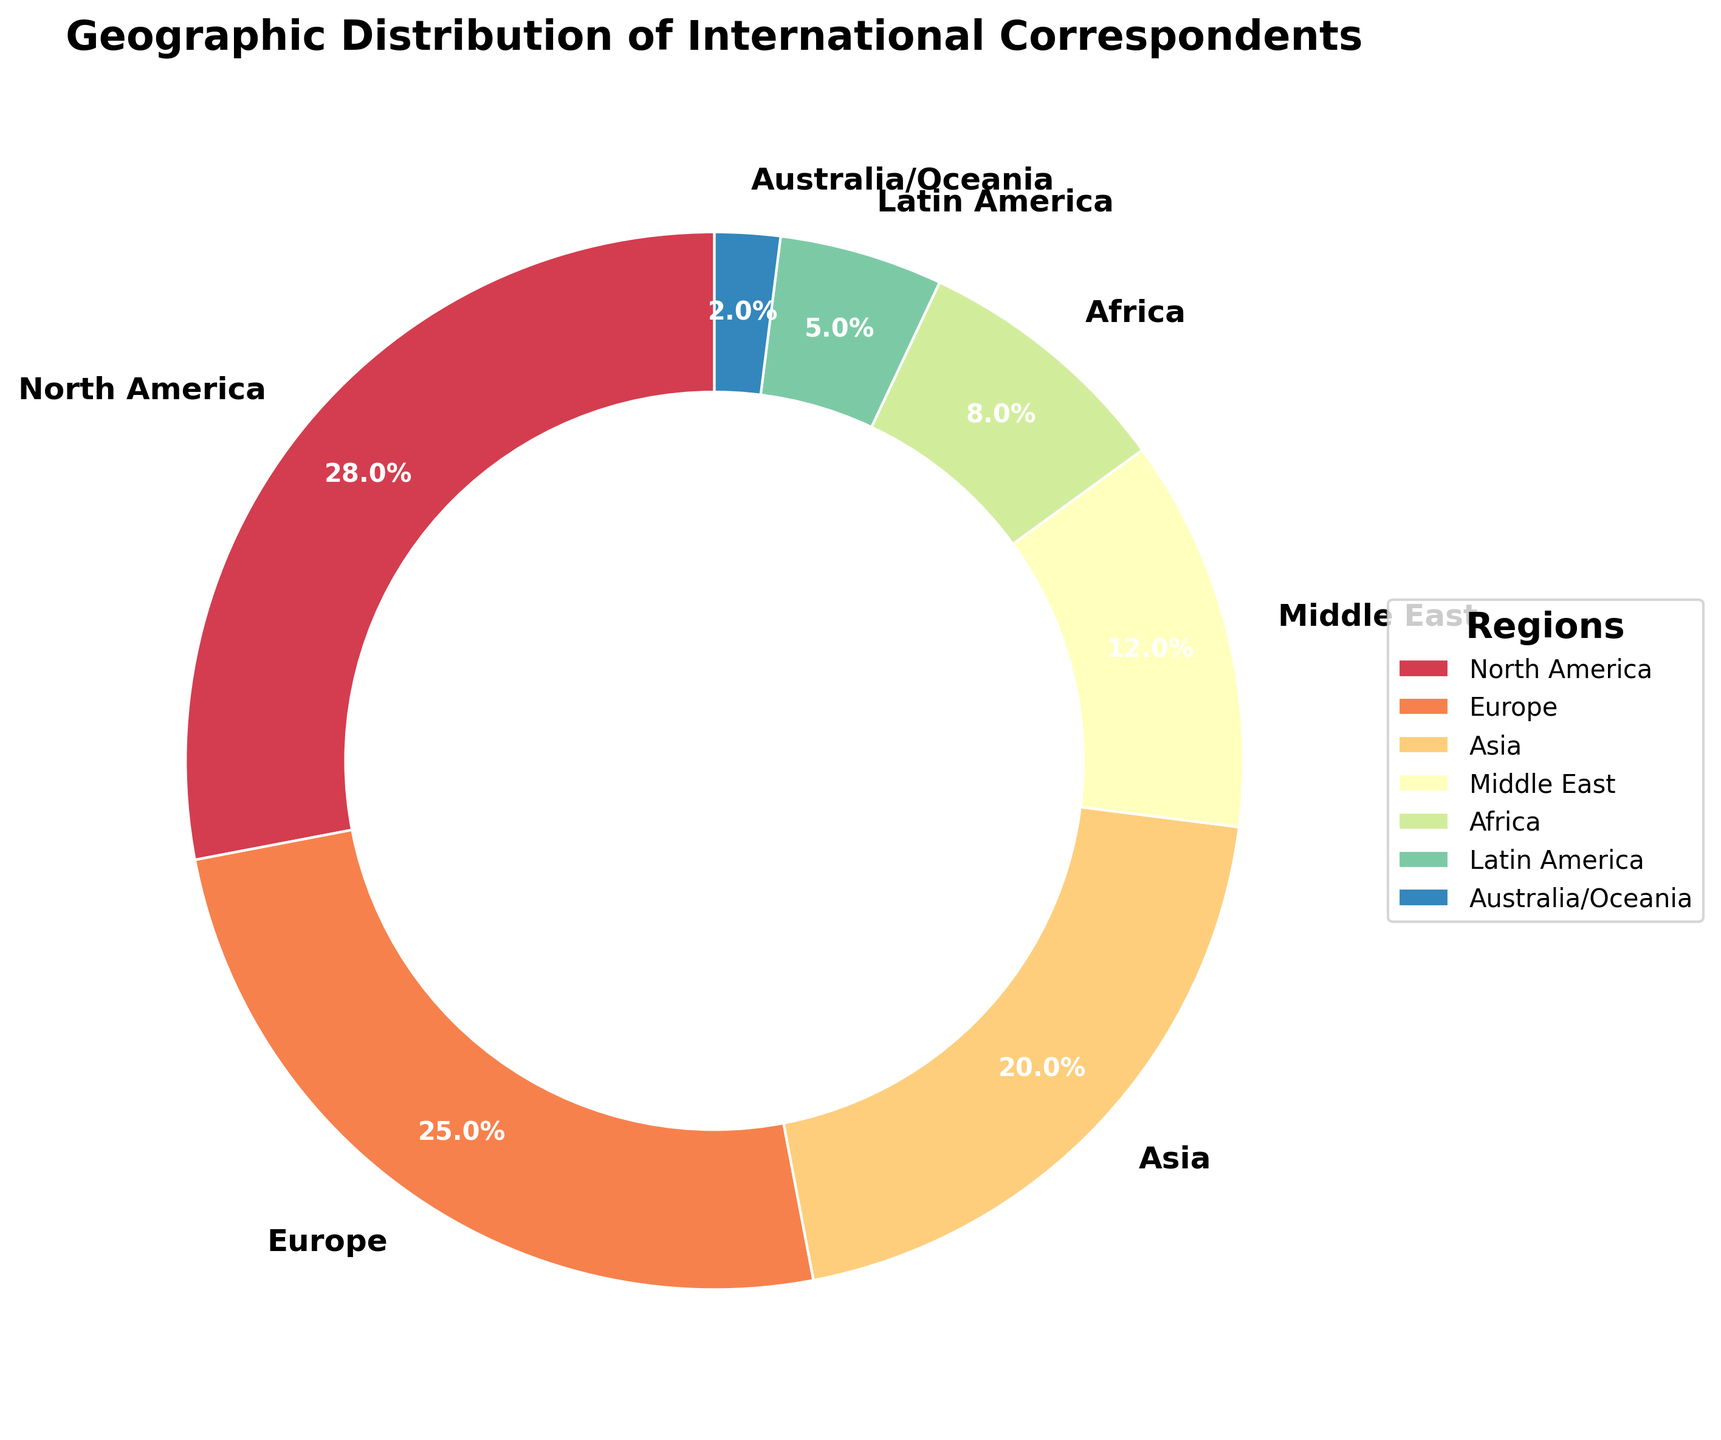Which region has the largest percentage of international correspondents? By looking at the figure, we can see that North America has the widest wedge segment, indicating the largest percentage.
Answer: North America Which regions combined make up more than 50% of the international correspondents? Adding the percentages of North America (28%) and Europe (25%) gives us 53%, which is more than 50%.
Answer: North America and Europe How much greater is the percentage of international correspondents in Asia compared to Australia/Oceania? According to the figure, Asia has 20% while Australia/Oceania has 2%. The difference is 20% - 2% = 18%.
Answer: 18% What is the percentage difference between the Middle East and Latin America? The Middle East has 12% and Latin America has 5%, so the difference is 12% - 5% = 7%.
Answer: 7% Which three regions have the smallest percentages of international correspondents? By looking at the wedges relative to each other, the regions with the smallest percentages are Australia/Oceania (2%), Latin America (5%), and Africa (8%).
Answer: Australia/Oceania, Latin America, and Africa What is the combined percentage of international correspondents in the Middle East and Africa? The Middle East has 12% and Africa has 8%. Adding them together gives 12% + 8% = 20%.
Answer: 20% Which region has a percentage closest to the average percentage of all regions? Adding the percentages: 28 + 25 + 20 + 12 + 8 + 5 + 2 = 100%. Dividing by 7 regions gives an average of approximately 14.3%. The Middle East, with 12%, is closest to this average.
Answer: Middle East How many regions have a percentage of international correspondents higher than 10%? North America (28%), Europe (25%), Asia (20%), and the Middle East (12%) all have more than 10%. There are 4 regions in total.
Answer: 4 